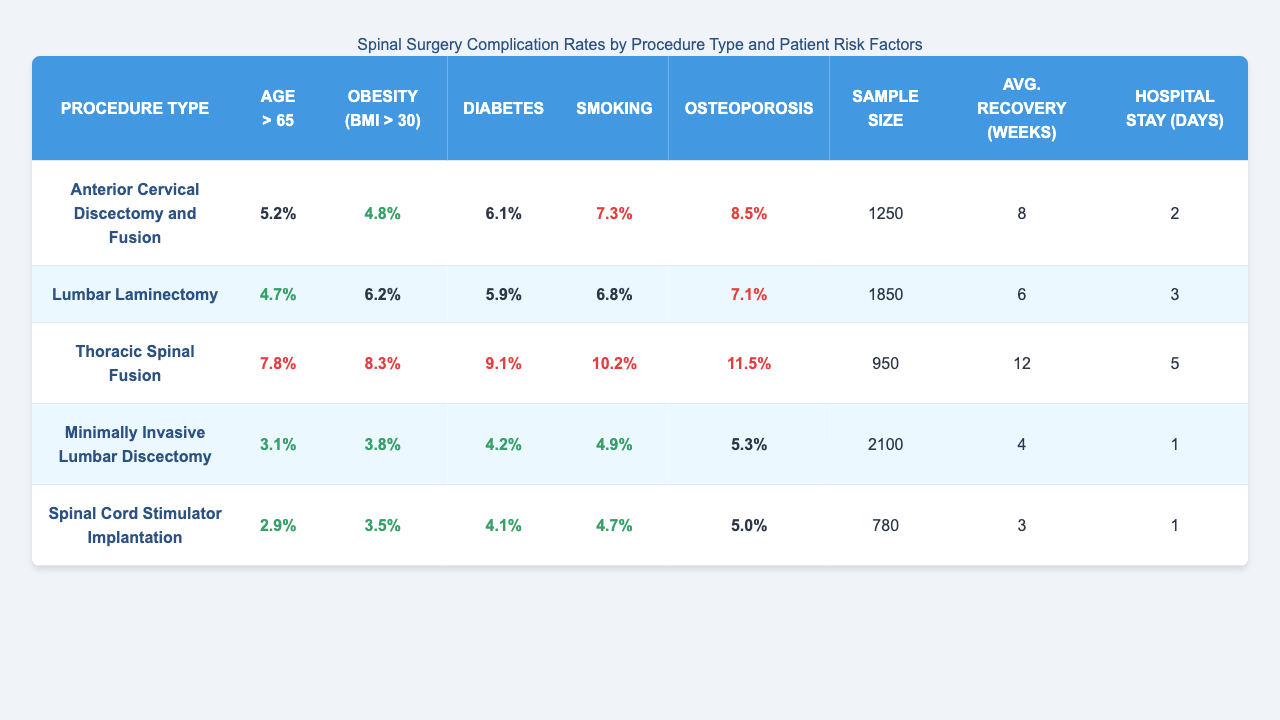What is the complication rate for "Thoracic Spinal Fusion" in patients with diabetes? According to the table, the complication rate for "Thoracic Spinal Fusion" in patients with diabetes is 9.1%.
Answer: 9.1% Which procedure has the highest complication rate for patients over 65 years old? The highest complication rate for patients over 65 years old is 7.8%, which corresponds to "Thoracic Spinal Fusion."
Answer: Thoracic Spinal Fusion What is the average recovery time for "Minimally Invasive Lumbar Discectomy"? The table shows that the average recovery time for "Minimally Invasive Lumbar Discectomy" is 4 weeks.
Answer: 4 weeks What is the difference in complication rates between "Lumbar Laminectomy" and "Spinal Cord Stimulator Implantation" for patients with obesity? The complication rate for "Lumbar Laminectomy" with obesity is 6.2%, while for "Spinal Cord Stimulator Implantation," it is 3.5%. The difference is 6.2% - 3.5% = 2.7%.
Answer: 2.7% Is the average hospital stay longer for patients undergoing "Thoracic Spinal Fusion" compared to "Anterior Cervical Discectomy and Fusion"? The average hospital stay for "Thoracic Spinal Fusion" is 5 days, while for "Anterior Cervical Discectomy and Fusion," it is 2 days. Since 5 days is greater than 2 days, the statement is true.
Answer: Yes Calculate the average complication rate for all procedures for patients with osteoporosis. The complication rates for osteoporosis are: 8.5%, 7.1%, 11.5%, 5.3%, and 5.0%. Summing these values gives 37.4%. Dividing by the number of procedures (5) gives an average of 37.4% / 5 = 7.48%.
Answer: 7.48% Which procedure type has the lowest complication rate for smoking? The procedure with the lowest complication rate for smoking is "Spinal Cord Stimulator Implantation," with a rate of 4.7%.
Answer: Spinal Cord Stimulator Implantation For patients with osteoporosis, which procedure has the highest complication rate? The complication rate for osteoporosis is highest in "Thoracic Spinal Fusion," which has a rate of 11.5%.
Answer: Thoracic Spinal Fusion What is the sample size for "Anterior Cervical Discectomy and Fusion"? The sample size for "Anterior Cervical Discectomy and Fusion" is provided in the table as 1250.
Answer: 1250 Are complication rates consistently higher for older patients across all procedure types? By evaluating the complication rates for "Age > 65" across each procedure, we find that they range from 2.9% (low) to 7.8% (higher). Thus, while most procedures do have rates trending higher for older patients, not every procedure shows a consistent increase.
Answer: No 